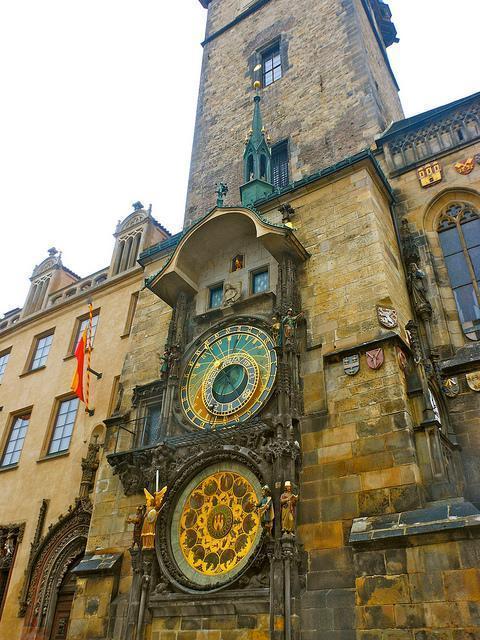How many clocks are there?
Give a very brief answer. 2. 